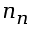Convert formula to latex. <formula><loc_0><loc_0><loc_500><loc_500>n _ { n }</formula> 